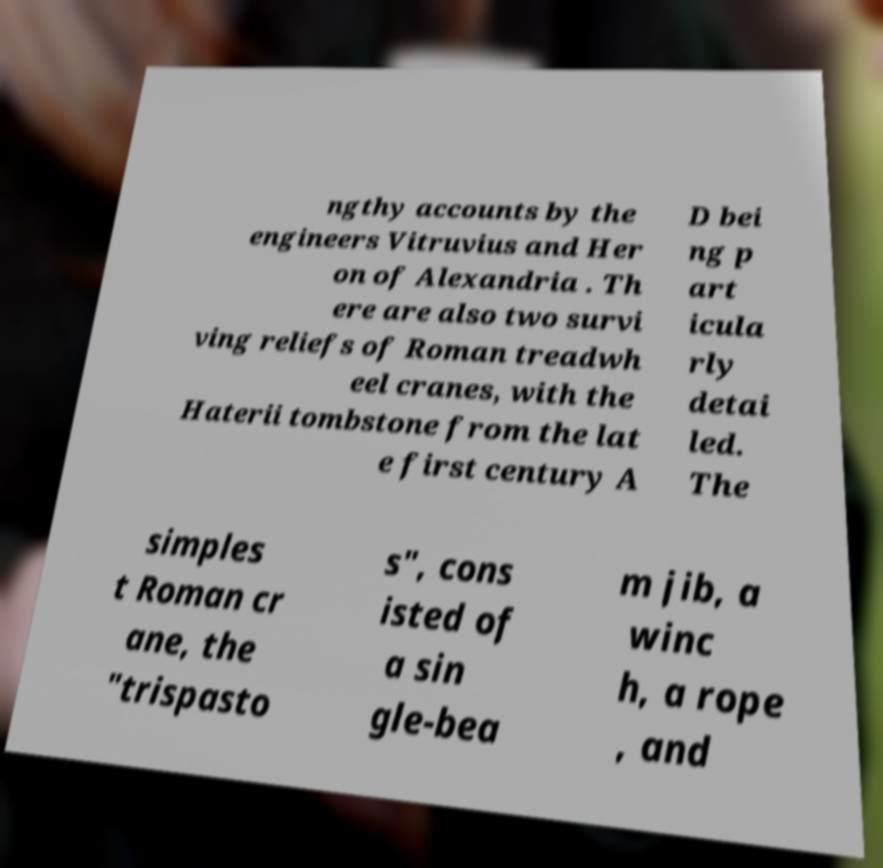What messages or text are displayed in this image? I need them in a readable, typed format. ngthy accounts by the engineers Vitruvius and Her on of Alexandria . Th ere are also two survi ving reliefs of Roman treadwh eel cranes, with the Haterii tombstone from the lat e first century A D bei ng p art icula rly detai led. The simples t Roman cr ane, the "trispasto s", cons isted of a sin gle-bea m jib, a winc h, a rope , and 